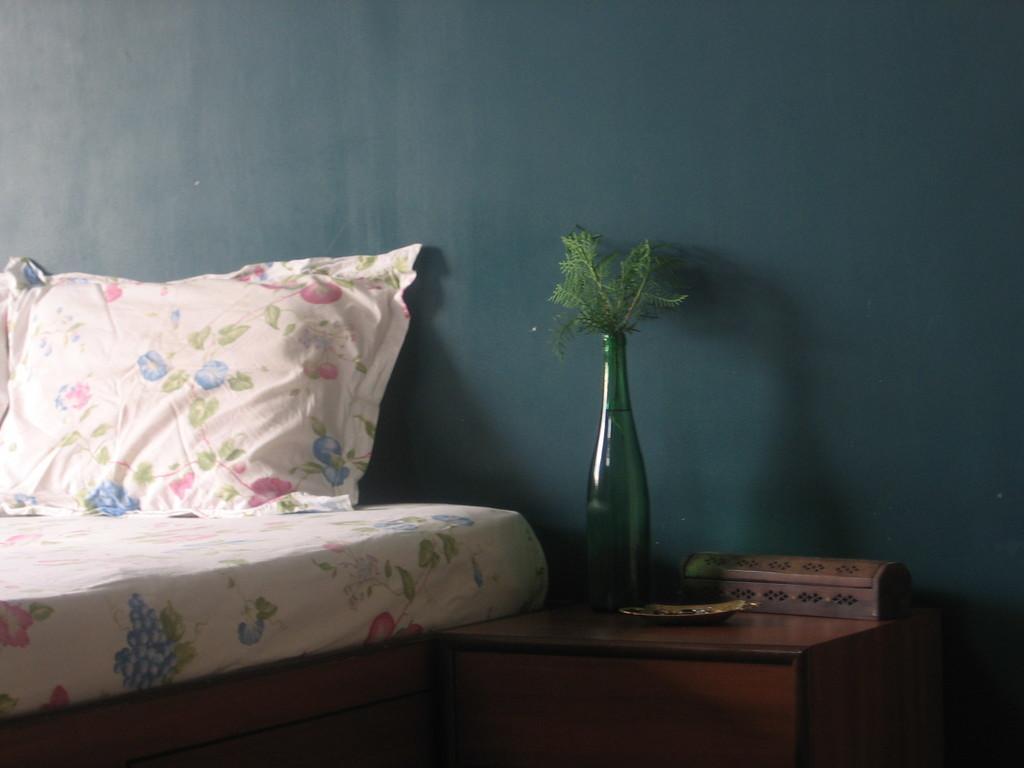Can you describe this image briefly? In the image there is bed with pillow and beside it there is a table with a glass bottle and background its wall. 